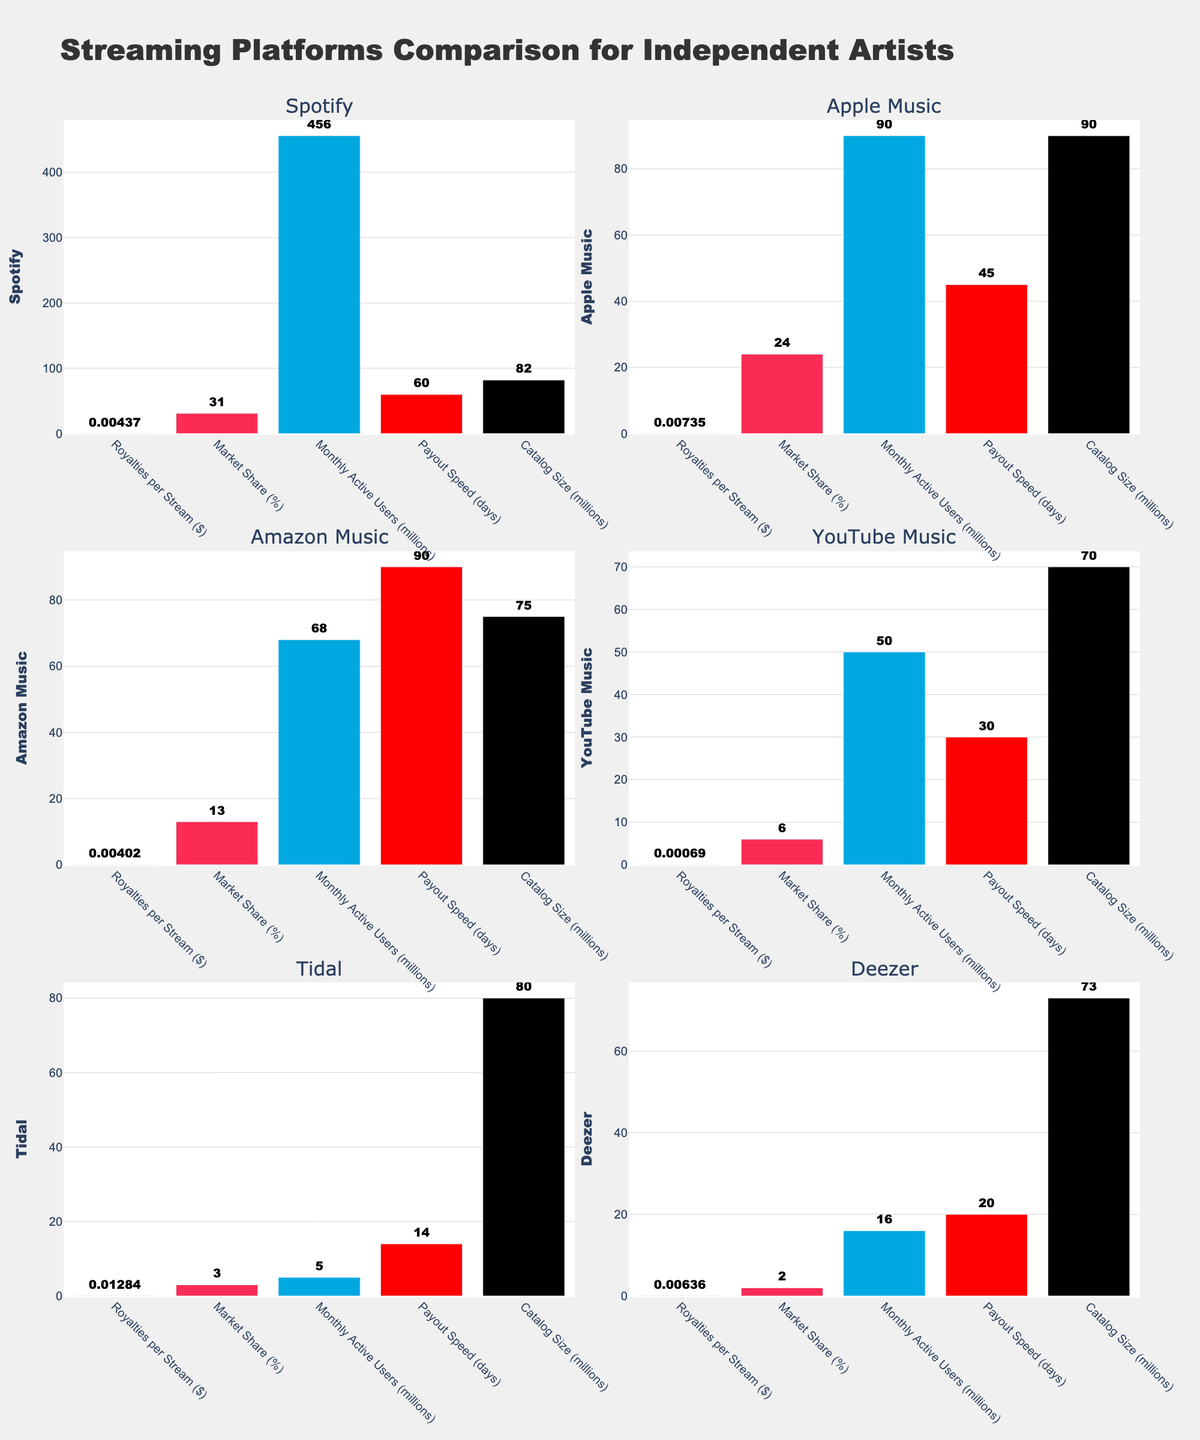Which platform has the highest royalties per stream? By looking at the "Royalties per Stream ($)" subplot, we can see the height of the bars representing different platforms. Tidal has the tallest bar in this subplot.
Answer: Tidal Which two platforms have the smallest market share? Referring to the "Market Share (%)" subplot, we can compare the heights of the bars. Deezer and Tidal have the shortest bars in this subplot.
Answer: Deezer and Tidal How many days does it take for Amazon Music to payout royalties? Looking at the "Payout Speed (days)" subplot, we check the height of Amazon Music's bar and read the value displayed above or near it.
Answer: 90 What is the monthly active user base of Spotify compared to YouTube Music? In the "Monthly Active Users (millions)" subplot, we compare the height of the Spotify and YouTube Music bars. Spotify's bar is much taller than YouTube Music's bar.
Answer: Spotify has 456 million, YouTube Music has 50 million Which streaming platform has the largest catalog size? Examining the "Catalog Size (millions)" subplot, we compare the heights of all bars. Apple Music has the tallest bar.
Answer: Apple Music What is the difference in royalties per stream between Apple Music and YouTube Music? In the "Royalties per Stream ($)" subplot, we find Apple Music's value (0.00735) and YouTube Music's value (0.00069). Subtracting the two gives us the difference: 0.00735 - 0.00069.
Answer: 0.00666 Which platform has the fastest payout speed and how many days does it take? Looking at the "Payout Speed (days)" subplot, we identify the shortest bar, which represents the fastest payout. Tidal has the shortest payout time.
Answer: Tidal, 14 days How does Deezer's payout speed compare to Spotify's? In the "Payout Speed (days)" subplot, we compare the heights of Deezer's and Spotify's bars. Deezer has a lower value (20 days) compared to Spotify (60 days).
Answer: Deezer is 40 days faster than Spotify What is the total market share for Spotify, Apple Music, and Amazon Music? In the "Market Share (%)" subplot, we add the values displayed above or near the bars of Spotify (31%), Apple Music (24%), and Amazon Music (13%).
Answer: 68% How does the royalties per stream of Deezer compare to those of Amazon Music? In the "Royalties per Stream ($)" subplot, comparing the bar heights of Deezer and Amazon Music shows that Deezer has a higher value.
Answer: Deezer pays more than Amazon Music 